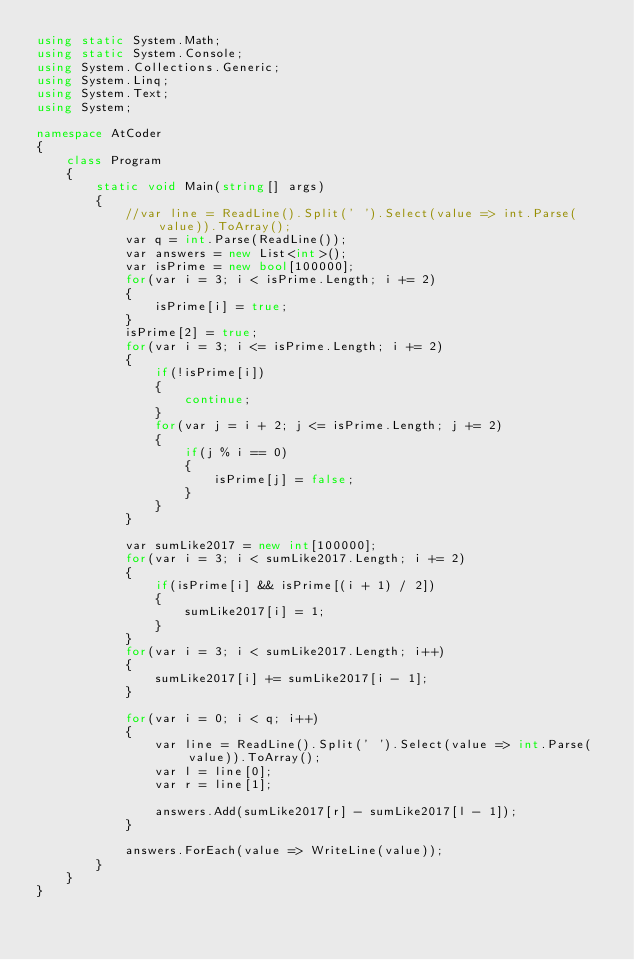Convert code to text. <code><loc_0><loc_0><loc_500><loc_500><_C#_>using static System.Math;
using static System.Console;
using System.Collections.Generic;
using System.Linq;
using System.Text;
using System;

namespace AtCoder
{
    class Program
    {
        static void Main(string[] args)
        {
            //var line = ReadLine().Split(' ').Select(value => int.Parse(value)).ToArray();
            var q = int.Parse(ReadLine());
            var answers = new List<int>();
            var isPrime = new bool[100000];
            for(var i = 3; i < isPrime.Length; i += 2)
            {
                isPrime[i] = true;
            }
            isPrime[2] = true;
            for(var i = 3; i <= isPrime.Length; i += 2)
            {
                if(!isPrime[i])
                {
                    continue;
                }
                for(var j = i + 2; j <= isPrime.Length; j += 2)
                {
                    if(j % i == 0)
                    {
                        isPrime[j] = false;
                    }
                }
            }

            var sumLike2017 = new int[100000];
            for(var i = 3; i < sumLike2017.Length; i += 2)
            {
                if(isPrime[i] && isPrime[(i + 1) / 2])
                {
                    sumLike2017[i] = 1;
                }
            }
            for(var i = 3; i < sumLike2017.Length; i++)
            {
                sumLike2017[i] += sumLike2017[i - 1];
            }

            for(var i = 0; i < q; i++)
            {
                var line = ReadLine().Split(' ').Select(value => int.Parse(value)).ToArray();
                var l = line[0];
                var r = line[1];

                answers.Add(sumLike2017[r] - sumLike2017[l - 1]);
            }

            answers.ForEach(value => WriteLine(value));
        }
    }
}
</code> 